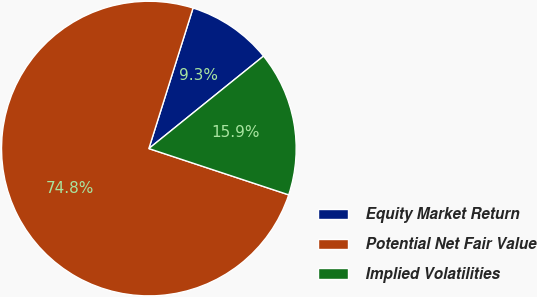<chart> <loc_0><loc_0><loc_500><loc_500><pie_chart><fcel>Equity Market Return<fcel>Potential Net Fair Value<fcel>Implied Volatilities<nl><fcel>9.35%<fcel>74.77%<fcel>15.89%<nl></chart> 